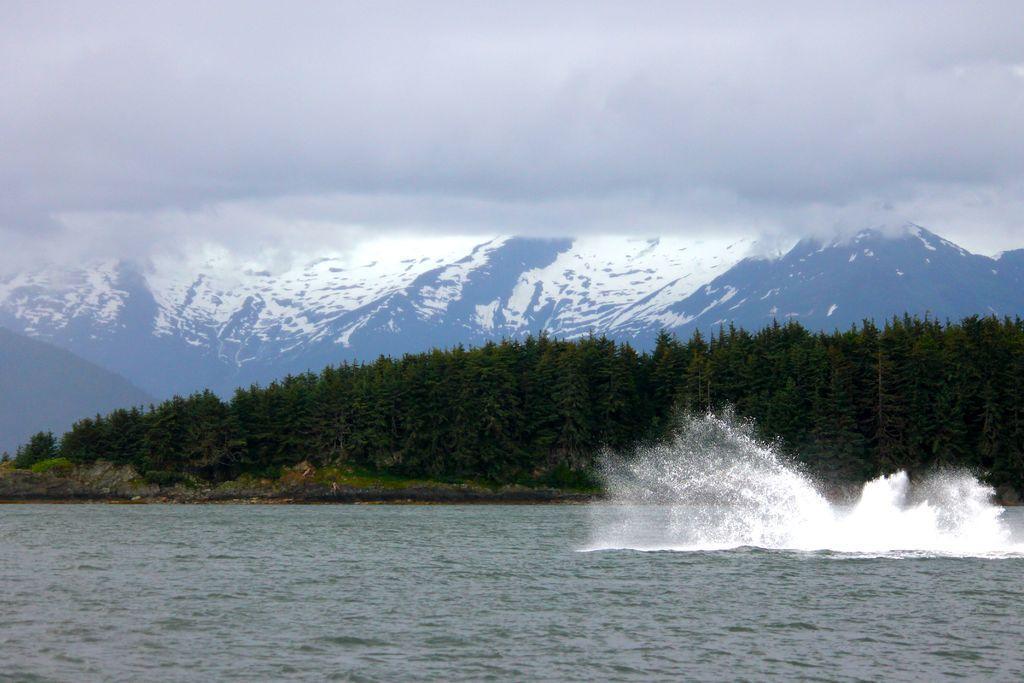Describe this image in one or two sentences. In this image, we can see so many trees. Background there are few mountains. At the bottom, we can see the sea. Top of the image, we can see a cloudy sky. 